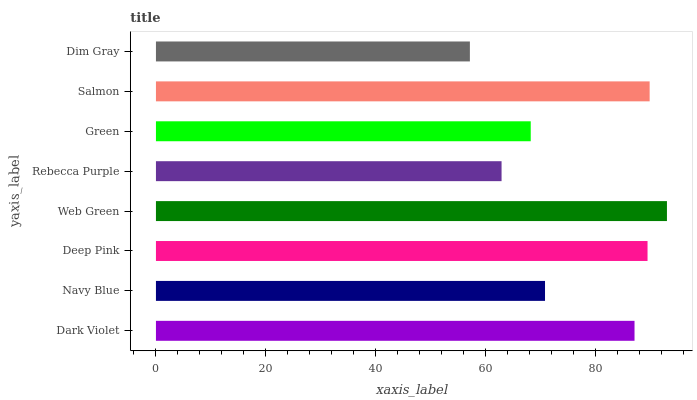Is Dim Gray the minimum?
Answer yes or no. Yes. Is Web Green the maximum?
Answer yes or no. Yes. Is Navy Blue the minimum?
Answer yes or no. No. Is Navy Blue the maximum?
Answer yes or no. No. Is Dark Violet greater than Navy Blue?
Answer yes or no. Yes. Is Navy Blue less than Dark Violet?
Answer yes or no. Yes. Is Navy Blue greater than Dark Violet?
Answer yes or no. No. Is Dark Violet less than Navy Blue?
Answer yes or no. No. Is Dark Violet the high median?
Answer yes or no. Yes. Is Navy Blue the low median?
Answer yes or no. Yes. Is Salmon the high median?
Answer yes or no. No. Is Green the low median?
Answer yes or no. No. 